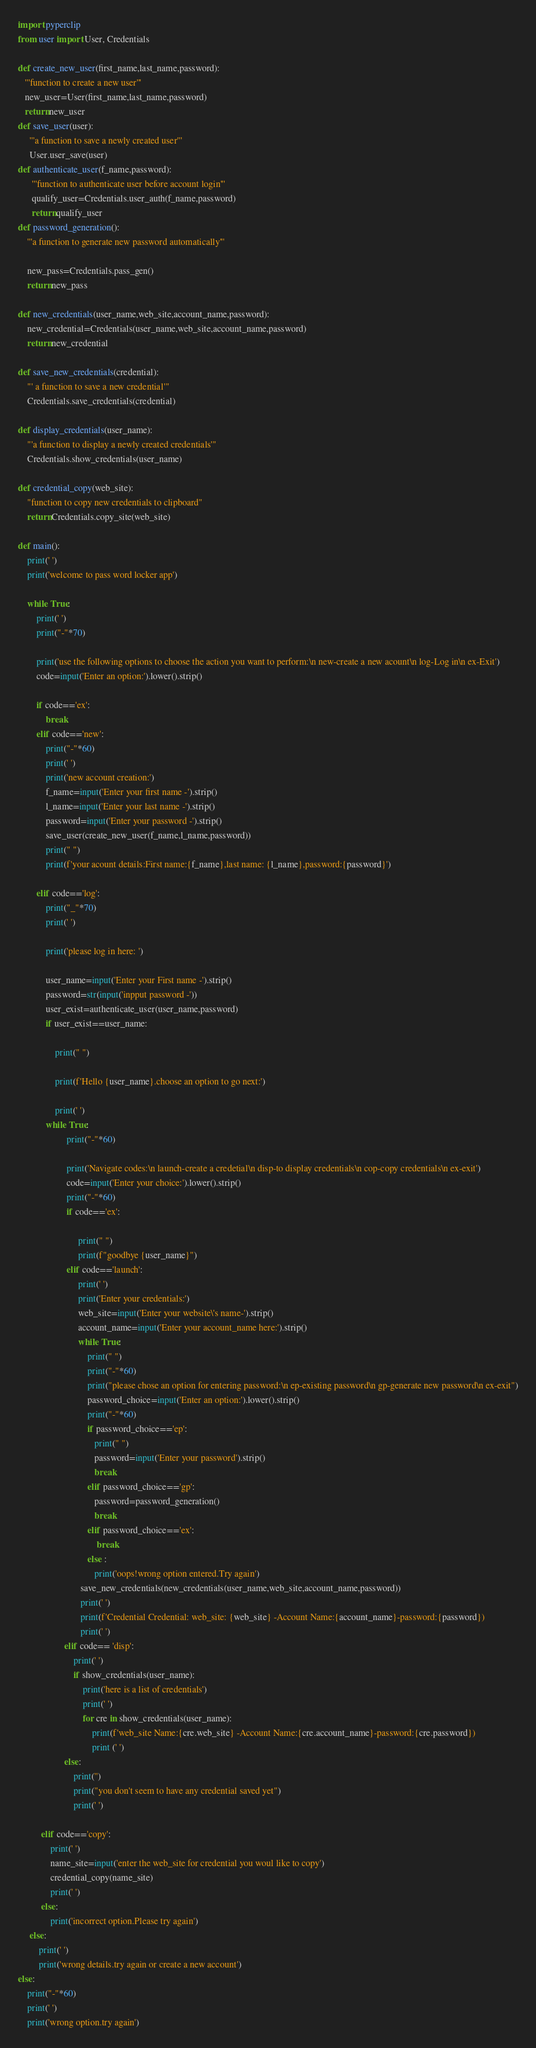Convert code to text. <code><loc_0><loc_0><loc_500><loc_500><_Python_>import pyperclip
from user import User, Credentials

def create_new_user(first_name,last_name,password):
   '''function to create a new user'''
   new_user=User(first_name,last_name,password)
   return new_user
def save_user(user):
     '''a function to save a newly created user'''
     User.user_save(user)
def authenticate_user(f_name,password):
      '''function to authenticate user before account login'''
      qualify_user=Credentials.user_auth(f_name,password)
      return qualify_user
def password_generation():
    '''a function to generate new password automatically'''

    new_pass=Credentials.pass_gen()
    return new_pass

def new_credentials(user_name,web_site,account_name,password):
    new_credential=Credentials(user_name,web_site,account_name,password)
    return new_credential

def save_new_credentials(credential):
    "' a function to save a new credential'"
    Credentials.save_credentials(credential)

def display_credentials(user_name):
    "'a function to display a newly created credentials'"
    Credentials.show_credentials(user_name)

def credential_copy(web_site):
    "function to copy new credentials to clipboard"
    return Credentials.copy_site(web_site)

def main():
    print(' ')
    print('welcome to pass word locker app')

    while True:
        print(' ')
        print("-"*70)

        print('use the following options to choose the action you want to perform:\n new-create a new acount\n log-Log in\n ex-Exit')
        code=input('Enter an option:').lower().strip()

        if code=='ex':
            break
        elif code=='new':
            print("-"*60)
            print(' ')
            print('new account creation:')
            f_name=input('Enter your first name -').strip()
            l_name=input('Enter your last name -').strip()
            password=input('Enter your password -').strip()
            save_user(create_new_user(f_name,l_name,password))
            print(" ")
            print(f'your acount details:First name:{f_name},last name: {l_name},password:{password}')

        elif code=='log':
            print("_"*70)
            print(' ')

            print('please log in here: ')

            user_name=input('Enter your First name -').strip()
            password=str(input('inpput password -'))
            user_exist=authenticate_user(user_name,password)
            if user_exist==user_name:

                print(" ")

                print(f'Hello {user_name}.choose an option to go next:')

                print(' ')
            while True:
                     print("-"*60)

                     print('Navigate codes:\n launch-create a credetial\n disp-to display credentials\n cop-copy credentials\n ex-exit')
                     code=input('Enter your choice:').lower().strip()
                     print("-"*60)
                     if code=='ex':

                          print(" ")
                          print(f"goodbye {user_name}")
                     elif code=='launch':
                          print(' ')
                          print('Enter your credentials:')
                          web_site=input('Enter your website\'s name-').strip()
                          account_name=input('Enter your account_name here:').strip()
                          while True:
                              print(" ")
                              print("-"*60)
                              print("please chose an option for entering password:\n ep-existing password\n gp-generate new password\n ex-exit")
                              password_choice=input('Enter an option:').lower().strip()
                              print("-"*60)
                              if password_choice=='ep':
                                 print(" ")
                                 password=input('Enter your password').strip()
                                 break
                              elif password_choice=='gp':
                                 password=password_generation()
                                 break
                              elif password_choice=='ex':
                                  break
                              else :
                                 print('oops!wrong option entered.Try again')
                           save_new_credentials(new_credentials(user_name,web_site,account_name,password))
                           print(' ')
                           print(f'Credential Credential: web_site: {web_site} -Account Name:{account_name}-password:{password})
                           print(' ')
                    elif code== 'disp':
                        print(' ')
                        if show_credentials(user_name):
                            print('here is a list of credentials')
                            print(' ')
                            for cre in show_credentials(user_name):
                                print(f'web_site Name:{cre.web_site} -Account Name:{cre.account_name}-password:{cre.password})
                                print (' ')
                    else:
                        print('')
                        print("you don't seem to have any credential saved yet")
                        print(' ')

          elif code=='copy':
              print(' ')
              name_site=input('enter the web_site for credential you woul like to copy')
              credential_copy(name_site)
              print(' ')
          else:
              print('incorrect option.Please try again')
     else:
         print(' ')
         print('wrong details.try again or create a new account')
else:
    print("-"*60)
    print(' ')
    print('wrong option.try again')

</code> 